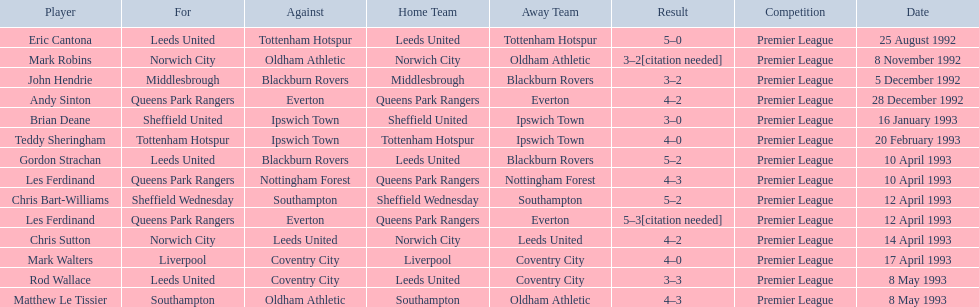What are the results? 5–0, 3–2[citation needed], 3–2, 4–2, 3–0, 4–0, 5–2, 4–3, 5–2, 5–3[citation needed], 4–2, 4–0, 3–3, 4–3. What result did mark robins have? 3–2[citation needed]. What other player had that result? John Hendrie. 